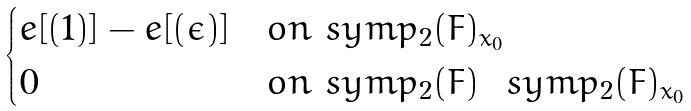<formula> <loc_0><loc_0><loc_500><loc_500>\begin{cases} e [ ( 1 ) ] - e [ ( \epsilon ) ] & o n \ s y m p _ { 2 } ( F ) _ { x _ { 0 } } \\ 0 & o n \ s y m p _ { 2 } ( F ) \ \ s y m p _ { 2 } ( F ) _ { x _ { 0 } } \end{cases}</formula> 